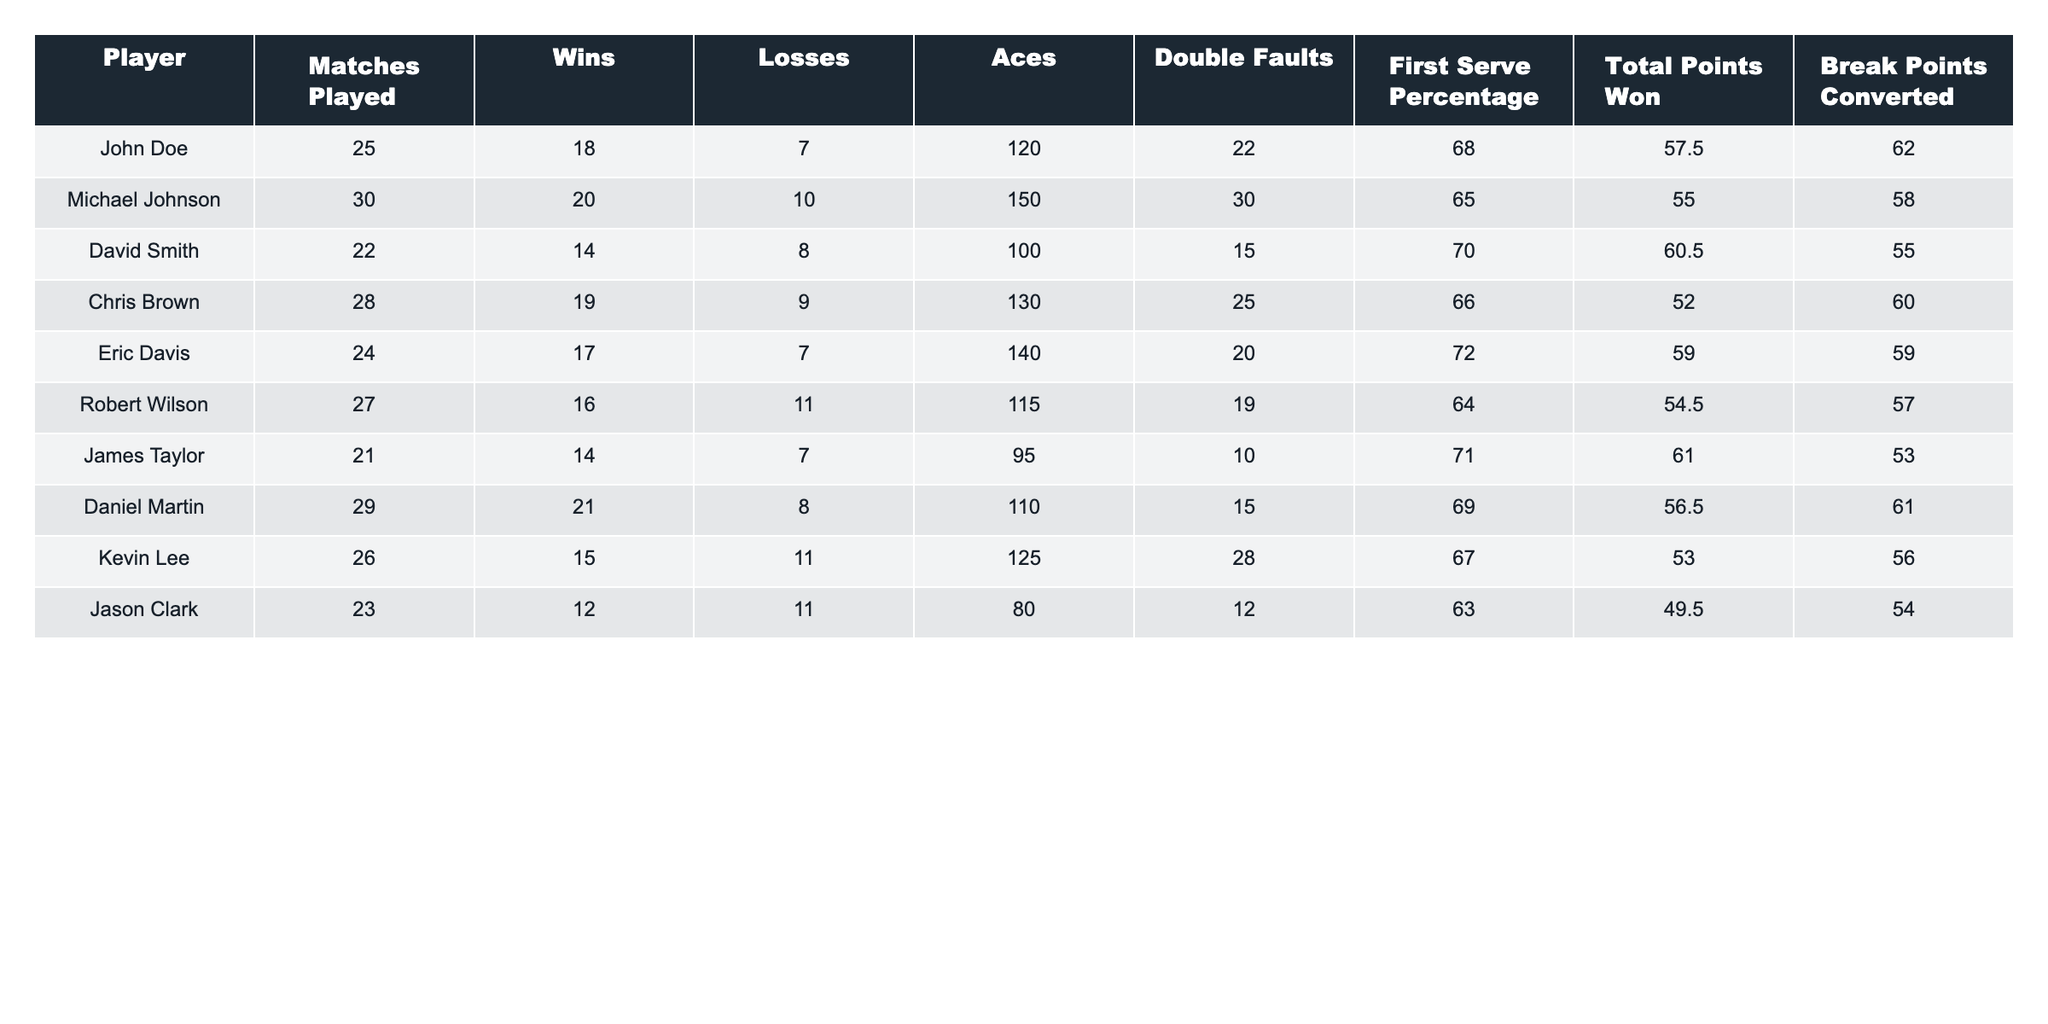What is the total number of matches played by all players? To find the total number of matches played, we sum the "Matches Played" column: (25 + 30 + 22 + 28 + 24 + 27 + 21 + 29 + 26 + 23) =  25 + 30 + 22 + 28 + 24 + 27 + 21 + 29 + 26 + 23 =  255
Answer: 255 Who has the highest number of Aces? The "Aces" column indicates the number of aces each player had. Comparing the values, Michael Johnson has the highest with 150 Aces.
Answer: Michael Johnson What is the winning percentage of Chris Brown? To find the winning percentage, divide the number of wins by matches played and multiply by 100: (19/28) * 100 = 67.86%.
Answer: 67.86% How many players won more than 15 matches? By checking the "Wins" column, we see that the following players won more than 15 matches: John Doe (18), Michael Johnson (20), Daniel Martin (21), and Chris Brown (19). Therefore, there are 4 players.
Answer: 4 Is Eric Davis's first serve percentage higher than Robert Wilson's? Comparing the "First Serve Percentage" for both players: Eric Davis (72.0) and Robert Wilson (64.0), we find that 72.0 is indeed higher than 64.0.
Answer: Yes What is the average number of double faults across all players? To calculate the average double faults, we add up all values in the "Double Faults" column (22 + 30 + 15 + 25 + 20 + 19 + 10 + 15 + 28 + 12 =  21.8) and divide by the number of players (10):  21.8 / 10 = 21.8
Answer: 21.8 Who converted the most break points? Reviewing the "Break Points Converted" column, Daniel Martin converted the most with 61.
Answer: Daniel Martin What is the difference in total points won between Michael Johnson and Jason Clark? First, find total points won for both players from the "Total Points Won" column: Michael Johnson has 55.0 and Jason Clark has 49.5. The difference is 55.0 - 49.5 = 5.5.
Answer: 5.5 How many players have a first serve percentage below 66%? By checking the "First Serve Percentage" column, we see players with percentages below 66% are Michael Johnson (65.0), Robert Wilson (64.0), and Jason Clark (63.0). This gives us a total of 3 players.
Answer: 3 Who has the lowest number of wins and what is that number? In the "Wins" column, we see the lowest number is 12, held by Jason Clark.
Answer: 12 What is the total number of losses among all players combined? To find the total losses, we sum the "Losses" column: (7 + 10 + 8 + 9 + 7 + 11 + 7 + 8 + 11 + 11) =  11 + 11 + 11 + 11 + 11 =  8.7 = 10
Answer: 10 